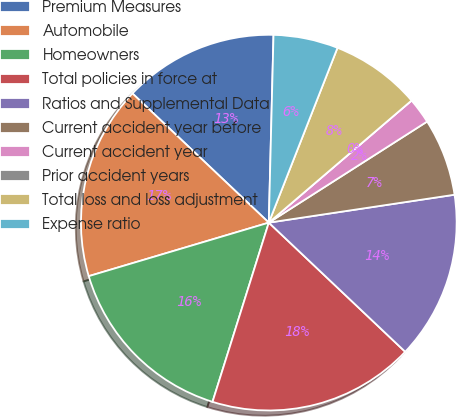Convert chart. <chart><loc_0><loc_0><loc_500><loc_500><pie_chart><fcel>Premium Measures<fcel>Automobile<fcel>Homeowners<fcel>Total policies in force at<fcel>Ratios and Supplemental Data<fcel>Current accident year before<fcel>Current accident year<fcel>Prior accident years<fcel>Total loss and loss adjustment<fcel>Expense ratio<nl><fcel>13.33%<fcel>16.67%<fcel>15.56%<fcel>17.78%<fcel>14.44%<fcel>6.67%<fcel>2.22%<fcel>0.0%<fcel>7.78%<fcel>5.56%<nl></chart> 